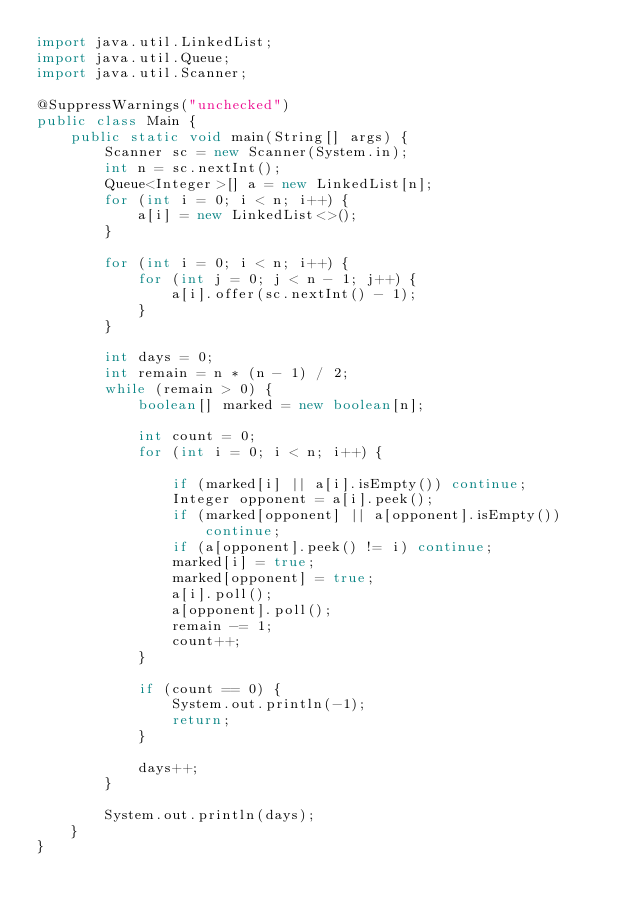<code> <loc_0><loc_0><loc_500><loc_500><_Java_>import java.util.LinkedList;
import java.util.Queue;
import java.util.Scanner;

@SuppressWarnings("unchecked")
public class Main {
	public static void main(String[] args) {
		Scanner sc = new Scanner(System.in);
		int n = sc.nextInt();
		Queue<Integer>[] a = new LinkedList[n];
		for (int i = 0; i < n; i++) {
			a[i] = new LinkedList<>();
		}

		for (int i = 0; i < n; i++) {
			for (int j = 0; j < n - 1; j++) {
				a[i].offer(sc.nextInt() - 1);
			}
		}

		int days = 0;
		int remain = n * (n - 1) / 2;
		while (remain > 0) {
			boolean[] marked = new boolean[n];

			int count = 0;
			for (int i = 0; i < n; i++) {

				if (marked[i] || a[i].isEmpty()) continue;
				Integer opponent = a[i].peek();
				if (marked[opponent] || a[opponent].isEmpty()) continue;
				if (a[opponent].peek() != i) continue;
				marked[i] = true;
				marked[opponent] = true;
				a[i].poll();
				a[opponent].poll();
				remain -= 1;
				count++;
			}

			if (count == 0) {
				System.out.println(-1);
				return;
			}

			days++;
		}

		System.out.println(days);
	}
}
</code> 